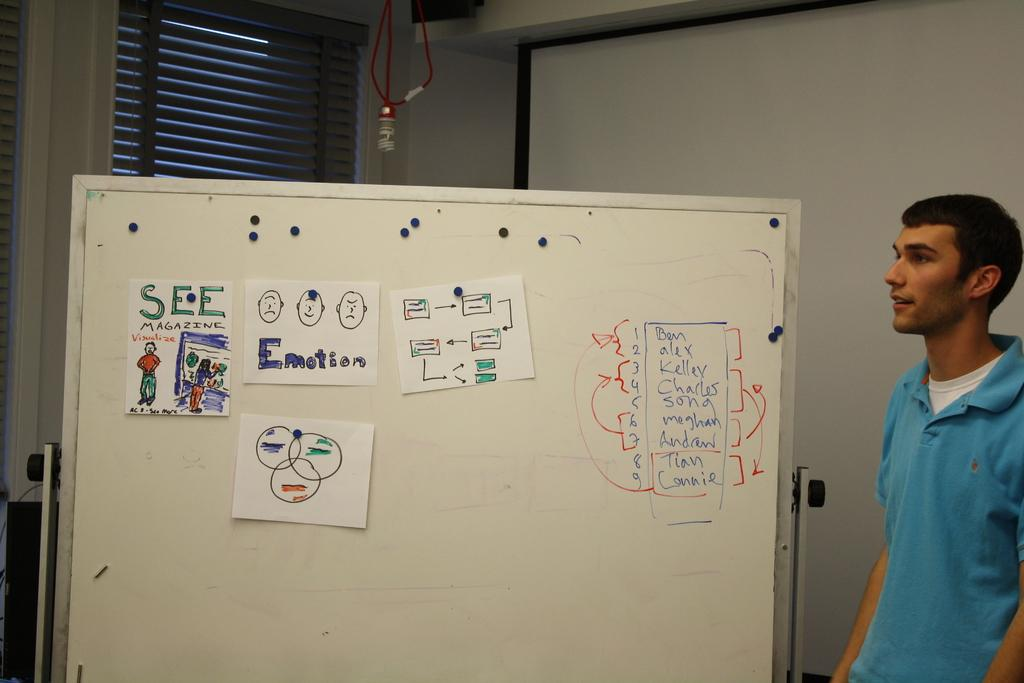<image>
Render a clear and concise summary of the photo. A man stands next to a whiteboard that has several sketches and charts for emotion. 